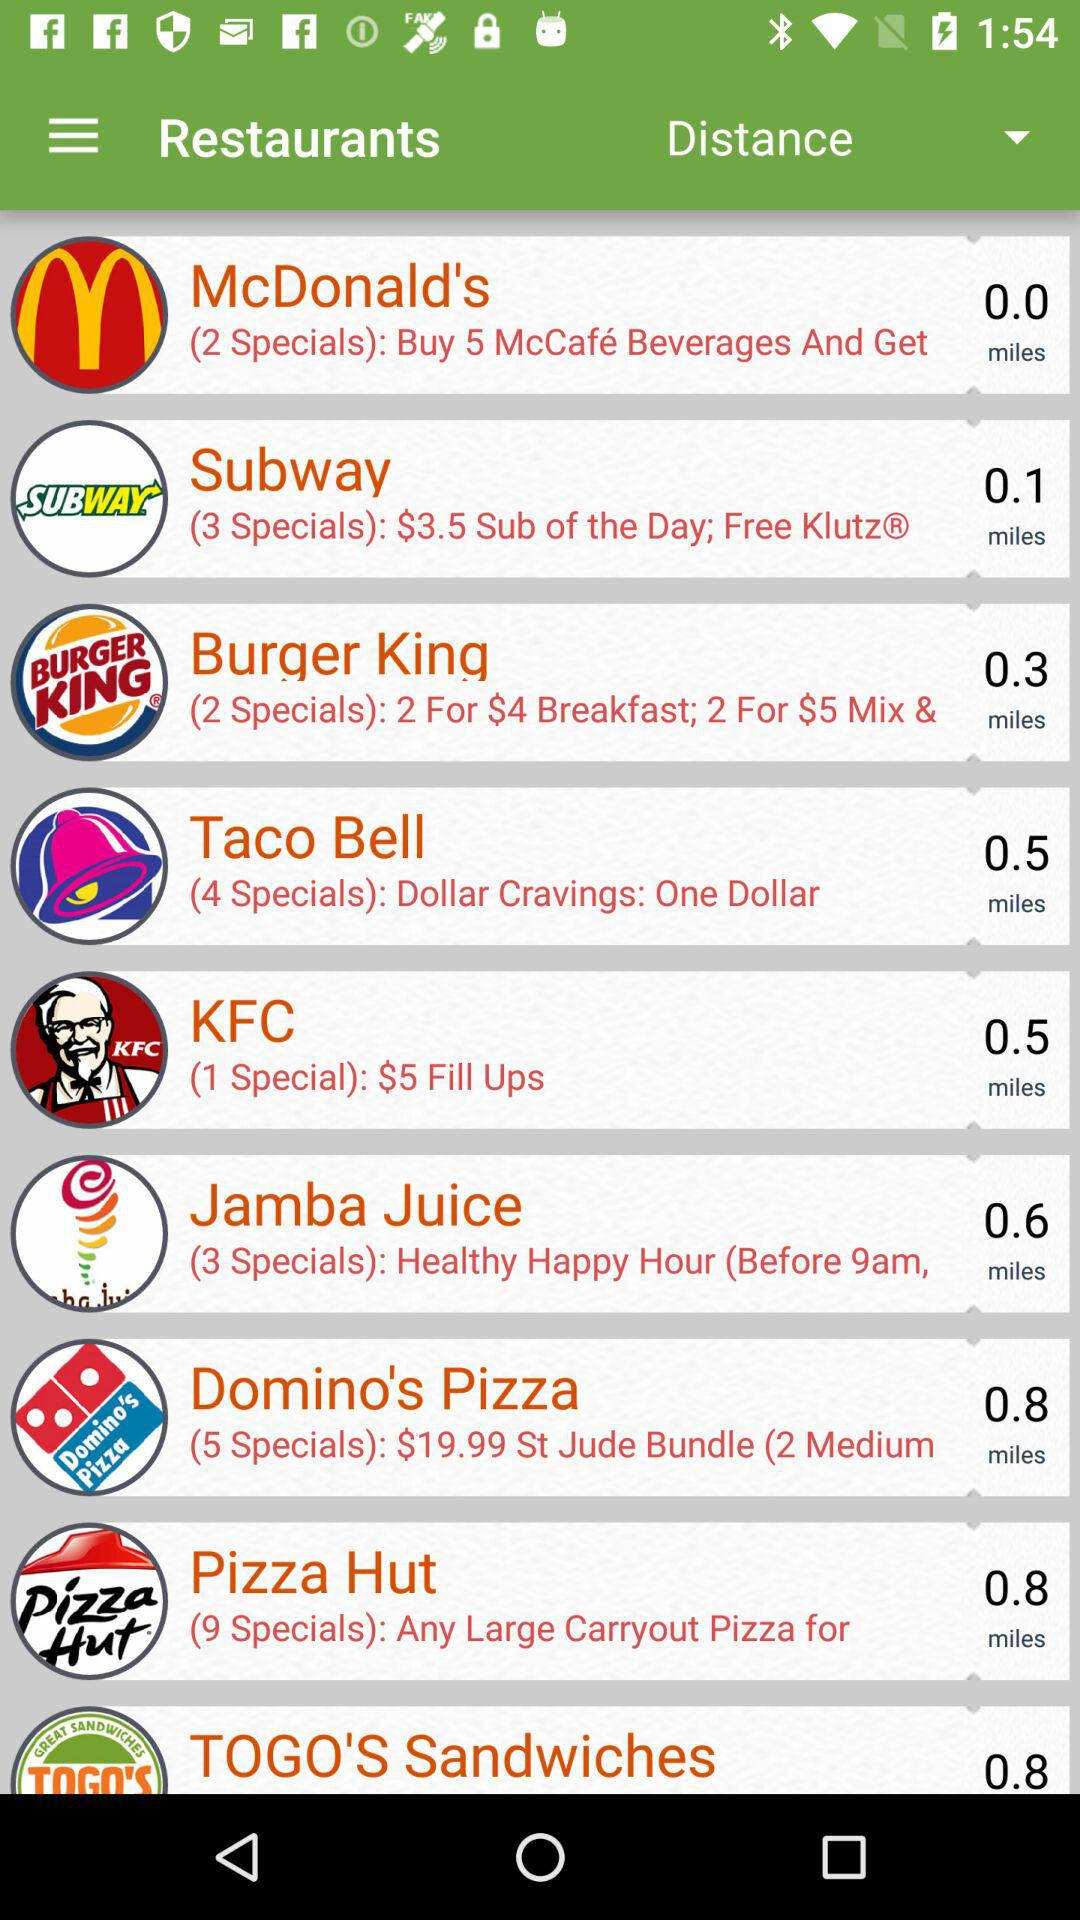Which restaurant is 0.0 miles away? The restaurant that is 0.0 miles away is McDonald's. 